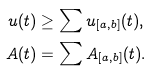<formula> <loc_0><loc_0><loc_500><loc_500>u ( t ) & \geq \sum u _ { [ a , b ] } ( t ) , \\ A ( t ) & = \sum A _ { [ a , b ] } ( t ) .</formula> 